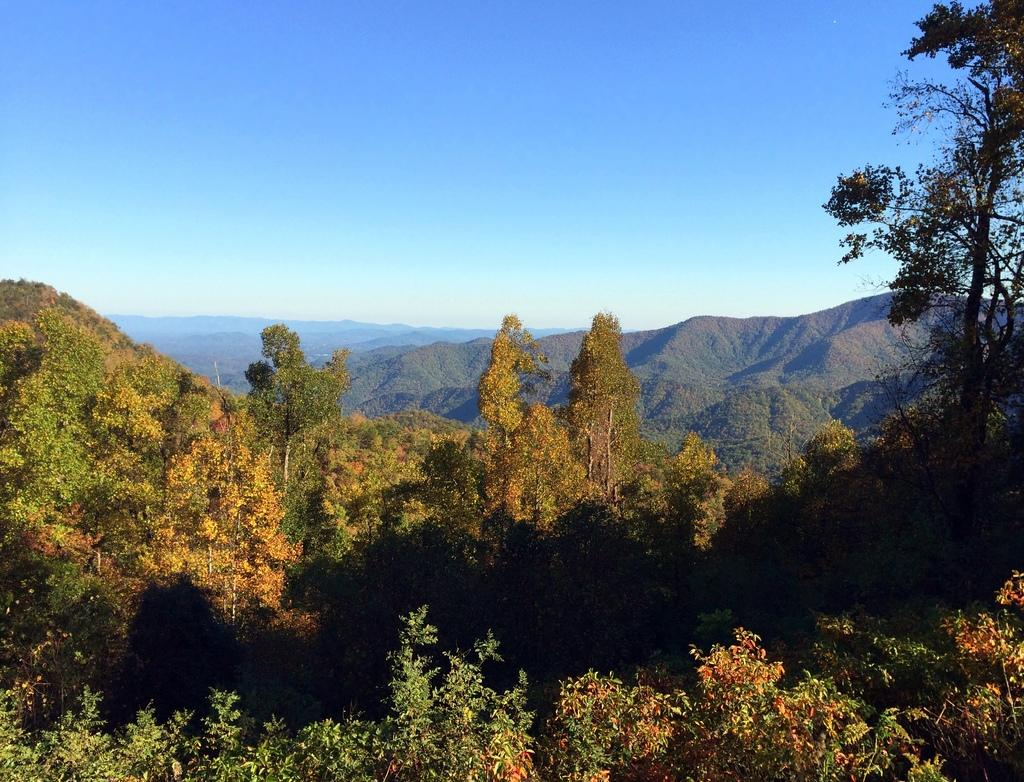What type of vegetation is present in the image? There are many trees in the image. What else can be seen on the ground in the image? There is grass in the image. What type of landscape feature is visible in the distance? There are mountains in the image. What is visible above the landscape in the image? The sky is visible in the image. How many sand dunes are visible in the image? There are no sand dunes present in the image; it features trees, grass, mountains, and the sky. What type of bird can be seen flying in the image? There are no birds visible in the image. 